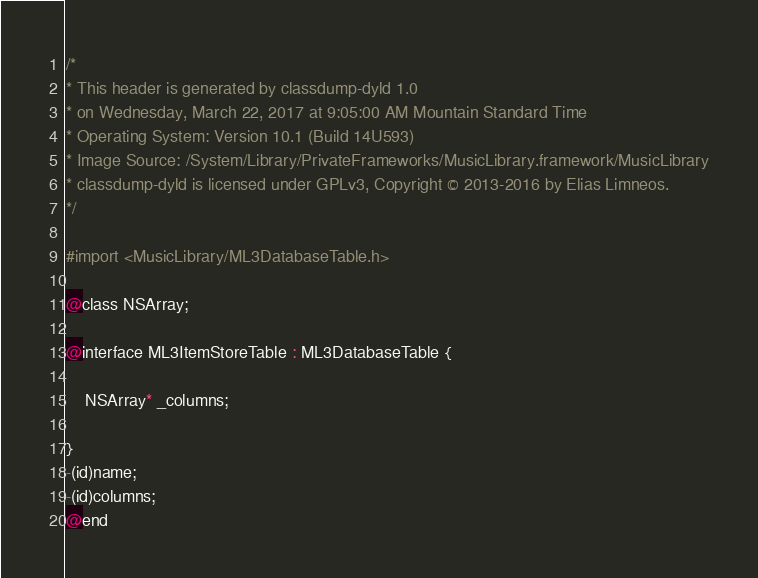<code> <loc_0><loc_0><loc_500><loc_500><_C_>/*
* This header is generated by classdump-dyld 1.0
* on Wednesday, March 22, 2017 at 9:05:00 AM Mountain Standard Time
* Operating System: Version 10.1 (Build 14U593)
* Image Source: /System/Library/PrivateFrameworks/MusicLibrary.framework/MusicLibrary
* classdump-dyld is licensed under GPLv3, Copyright © 2013-2016 by Elias Limneos.
*/

#import <MusicLibrary/ML3DatabaseTable.h>

@class NSArray;

@interface ML3ItemStoreTable : ML3DatabaseTable {

	NSArray* _columns;

}
-(id)name;
-(id)columns;
@end

</code> 